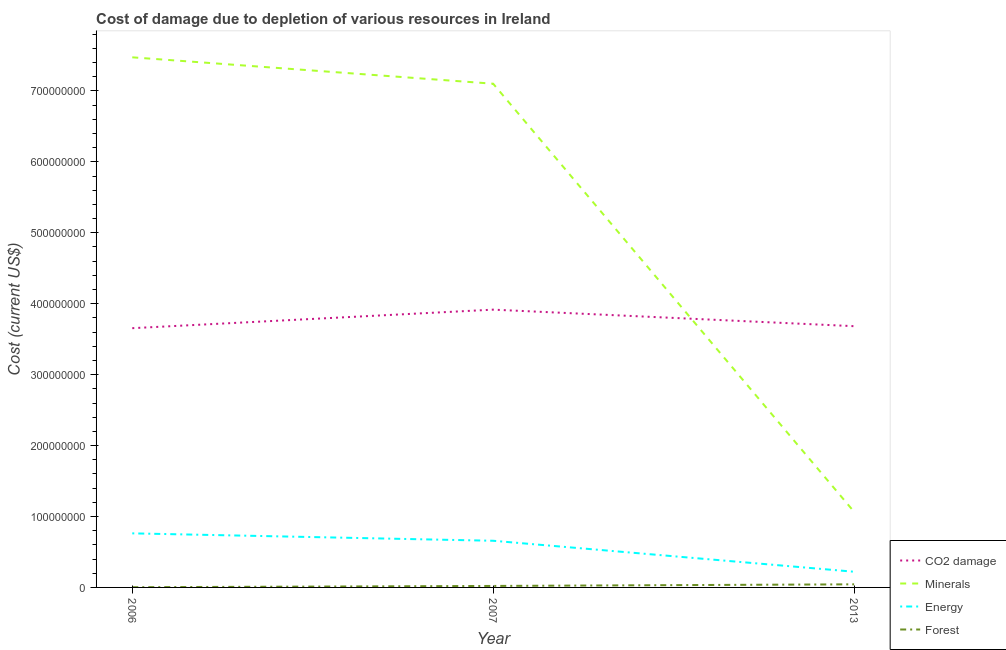Is the number of lines equal to the number of legend labels?
Give a very brief answer. Yes. What is the cost of damage due to depletion of forests in 2007?
Keep it short and to the point. 2.10e+06. Across all years, what is the maximum cost of damage due to depletion of minerals?
Ensure brevity in your answer.  7.47e+08. Across all years, what is the minimum cost of damage due to depletion of coal?
Your answer should be very brief. 3.65e+08. In which year was the cost of damage due to depletion of coal maximum?
Ensure brevity in your answer.  2007. In which year was the cost of damage due to depletion of forests minimum?
Your answer should be compact. 2006. What is the total cost of damage due to depletion of coal in the graph?
Provide a short and direct response. 1.13e+09. What is the difference between the cost of damage due to depletion of energy in 2006 and that in 2007?
Offer a very short reply. 1.05e+07. What is the difference between the cost of damage due to depletion of energy in 2007 and the cost of damage due to depletion of coal in 2013?
Provide a succinct answer. -3.03e+08. What is the average cost of damage due to depletion of energy per year?
Provide a succinct answer. 5.47e+07. In the year 2013, what is the difference between the cost of damage due to depletion of energy and cost of damage due to depletion of minerals?
Make the answer very short. -8.45e+07. What is the ratio of the cost of damage due to depletion of minerals in 2006 to that in 2007?
Your answer should be compact. 1.05. Is the cost of damage due to depletion of coal in 2006 less than that in 2007?
Your response must be concise. Yes. What is the difference between the highest and the second highest cost of damage due to depletion of minerals?
Offer a terse response. 3.72e+07. What is the difference between the highest and the lowest cost of damage due to depletion of forests?
Your answer should be compact. 4.07e+06. Is the sum of the cost of damage due to depletion of coal in 2007 and 2013 greater than the maximum cost of damage due to depletion of energy across all years?
Offer a very short reply. Yes. Is it the case that in every year, the sum of the cost of damage due to depletion of minerals and cost of damage due to depletion of forests is greater than the sum of cost of damage due to depletion of energy and cost of damage due to depletion of coal?
Keep it short and to the point. No. Is it the case that in every year, the sum of the cost of damage due to depletion of coal and cost of damage due to depletion of minerals is greater than the cost of damage due to depletion of energy?
Your answer should be very brief. Yes. Does the cost of damage due to depletion of coal monotonically increase over the years?
Provide a succinct answer. No. Is the cost of damage due to depletion of energy strictly greater than the cost of damage due to depletion of minerals over the years?
Your response must be concise. No. Where does the legend appear in the graph?
Offer a very short reply. Bottom right. What is the title of the graph?
Offer a very short reply. Cost of damage due to depletion of various resources in Ireland . Does "UNAIDS" appear as one of the legend labels in the graph?
Your response must be concise. No. What is the label or title of the Y-axis?
Keep it short and to the point. Cost (current US$). What is the Cost (current US$) of CO2 damage in 2006?
Give a very brief answer. 3.65e+08. What is the Cost (current US$) of Minerals in 2006?
Offer a very short reply. 7.47e+08. What is the Cost (current US$) in Energy in 2006?
Provide a short and direct response. 7.62e+07. What is the Cost (current US$) of Forest in 2006?
Your response must be concise. 2.94e+05. What is the Cost (current US$) in CO2 damage in 2007?
Provide a succinct answer. 3.92e+08. What is the Cost (current US$) in Minerals in 2007?
Your response must be concise. 7.10e+08. What is the Cost (current US$) of Energy in 2007?
Your response must be concise. 6.58e+07. What is the Cost (current US$) of Forest in 2007?
Give a very brief answer. 2.10e+06. What is the Cost (current US$) of CO2 damage in 2013?
Your answer should be very brief. 3.68e+08. What is the Cost (current US$) in Minerals in 2013?
Provide a short and direct response. 1.07e+08. What is the Cost (current US$) of Energy in 2013?
Keep it short and to the point. 2.21e+07. What is the Cost (current US$) in Forest in 2013?
Your answer should be compact. 4.37e+06. Across all years, what is the maximum Cost (current US$) of CO2 damage?
Your answer should be very brief. 3.92e+08. Across all years, what is the maximum Cost (current US$) of Minerals?
Your answer should be very brief. 7.47e+08. Across all years, what is the maximum Cost (current US$) of Energy?
Offer a very short reply. 7.62e+07. Across all years, what is the maximum Cost (current US$) of Forest?
Your answer should be compact. 4.37e+06. Across all years, what is the minimum Cost (current US$) of CO2 damage?
Your response must be concise. 3.65e+08. Across all years, what is the minimum Cost (current US$) in Minerals?
Ensure brevity in your answer.  1.07e+08. Across all years, what is the minimum Cost (current US$) of Energy?
Your response must be concise. 2.21e+07. Across all years, what is the minimum Cost (current US$) in Forest?
Keep it short and to the point. 2.94e+05. What is the total Cost (current US$) in CO2 damage in the graph?
Provide a succinct answer. 1.13e+09. What is the total Cost (current US$) of Minerals in the graph?
Provide a succinct answer. 1.56e+09. What is the total Cost (current US$) in Energy in the graph?
Provide a short and direct response. 1.64e+08. What is the total Cost (current US$) in Forest in the graph?
Your answer should be very brief. 6.76e+06. What is the difference between the Cost (current US$) in CO2 damage in 2006 and that in 2007?
Provide a succinct answer. -2.61e+07. What is the difference between the Cost (current US$) of Minerals in 2006 and that in 2007?
Offer a terse response. 3.72e+07. What is the difference between the Cost (current US$) of Energy in 2006 and that in 2007?
Give a very brief answer. 1.05e+07. What is the difference between the Cost (current US$) of Forest in 2006 and that in 2007?
Give a very brief answer. -1.81e+06. What is the difference between the Cost (current US$) in CO2 damage in 2006 and that in 2013?
Ensure brevity in your answer.  -2.81e+06. What is the difference between the Cost (current US$) in Minerals in 2006 and that in 2013?
Your answer should be compact. 6.41e+08. What is the difference between the Cost (current US$) of Energy in 2006 and that in 2013?
Ensure brevity in your answer.  5.41e+07. What is the difference between the Cost (current US$) of Forest in 2006 and that in 2013?
Give a very brief answer. -4.07e+06. What is the difference between the Cost (current US$) in CO2 damage in 2007 and that in 2013?
Your response must be concise. 2.33e+07. What is the difference between the Cost (current US$) in Minerals in 2007 and that in 2013?
Provide a short and direct response. 6.04e+08. What is the difference between the Cost (current US$) in Energy in 2007 and that in 2013?
Your answer should be very brief. 4.37e+07. What is the difference between the Cost (current US$) in Forest in 2007 and that in 2013?
Provide a short and direct response. -2.27e+06. What is the difference between the Cost (current US$) of CO2 damage in 2006 and the Cost (current US$) of Minerals in 2007?
Your answer should be compact. -3.45e+08. What is the difference between the Cost (current US$) in CO2 damage in 2006 and the Cost (current US$) in Energy in 2007?
Your response must be concise. 3.00e+08. What is the difference between the Cost (current US$) of CO2 damage in 2006 and the Cost (current US$) of Forest in 2007?
Your response must be concise. 3.63e+08. What is the difference between the Cost (current US$) in Minerals in 2006 and the Cost (current US$) in Energy in 2007?
Provide a short and direct response. 6.82e+08. What is the difference between the Cost (current US$) in Minerals in 2006 and the Cost (current US$) in Forest in 2007?
Your answer should be compact. 7.45e+08. What is the difference between the Cost (current US$) of Energy in 2006 and the Cost (current US$) of Forest in 2007?
Your answer should be very brief. 7.41e+07. What is the difference between the Cost (current US$) in CO2 damage in 2006 and the Cost (current US$) in Minerals in 2013?
Make the answer very short. 2.59e+08. What is the difference between the Cost (current US$) in CO2 damage in 2006 and the Cost (current US$) in Energy in 2013?
Provide a short and direct response. 3.43e+08. What is the difference between the Cost (current US$) in CO2 damage in 2006 and the Cost (current US$) in Forest in 2013?
Give a very brief answer. 3.61e+08. What is the difference between the Cost (current US$) of Minerals in 2006 and the Cost (current US$) of Energy in 2013?
Your response must be concise. 7.25e+08. What is the difference between the Cost (current US$) in Minerals in 2006 and the Cost (current US$) in Forest in 2013?
Your answer should be compact. 7.43e+08. What is the difference between the Cost (current US$) of Energy in 2006 and the Cost (current US$) of Forest in 2013?
Keep it short and to the point. 7.19e+07. What is the difference between the Cost (current US$) in CO2 damage in 2007 and the Cost (current US$) in Minerals in 2013?
Keep it short and to the point. 2.85e+08. What is the difference between the Cost (current US$) in CO2 damage in 2007 and the Cost (current US$) in Energy in 2013?
Offer a terse response. 3.70e+08. What is the difference between the Cost (current US$) of CO2 damage in 2007 and the Cost (current US$) of Forest in 2013?
Offer a terse response. 3.87e+08. What is the difference between the Cost (current US$) of Minerals in 2007 and the Cost (current US$) of Energy in 2013?
Offer a terse response. 6.88e+08. What is the difference between the Cost (current US$) in Minerals in 2007 and the Cost (current US$) in Forest in 2013?
Offer a very short reply. 7.06e+08. What is the difference between the Cost (current US$) of Energy in 2007 and the Cost (current US$) of Forest in 2013?
Keep it short and to the point. 6.14e+07. What is the average Cost (current US$) in CO2 damage per year?
Ensure brevity in your answer.  3.75e+08. What is the average Cost (current US$) in Minerals per year?
Keep it short and to the point. 5.21e+08. What is the average Cost (current US$) in Energy per year?
Make the answer very short. 5.47e+07. What is the average Cost (current US$) in Forest per year?
Give a very brief answer. 2.25e+06. In the year 2006, what is the difference between the Cost (current US$) of CO2 damage and Cost (current US$) of Minerals?
Provide a succinct answer. -3.82e+08. In the year 2006, what is the difference between the Cost (current US$) in CO2 damage and Cost (current US$) in Energy?
Your response must be concise. 2.89e+08. In the year 2006, what is the difference between the Cost (current US$) in CO2 damage and Cost (current US$) in Forest?
Your answer should be compact. 3.65e+08. In the year 2006, what is the difference between the Cost (current US$) in Minerals and Cost (current US$) in Energy?
Your answer should be compact. 6.71e+08. In the year 2006, what is the difference between the Cost (current US$) of Minerals and Cost (current US$) of Forest?
Give a very brief answer. 7.47e+08. In the year 2006, what is the difference between the Cost (current US$) in Energy and Cost (current US$) in Forest?
Provide a succinct answer. 7.59e+07. In the year 2007, what is the difference between the Cost (current US$) in CO2 damage and Cost (current US$) in Minerals?
Offer a terse response. -3.19e+08. In the year 2007, what is the difference between the Cost (current US$) in CO2 damage and Cost (current US$) in Energy?
Keep it short and to the point. 3.26e+08. In the year 2007, what is the difference between the Cost (current US$) in CO2 damage and Cost (current US$) in Forest?
Your answer should be very brief. 3.90e+08. In the year 2007, what is the difference between the Cost (current US$) in Minerals and Cost (current US$) in Energy?
Your response must be concise. 6.44e+08. In the year 2007, what is the difference between the Cost (current US$) of Minerals and Cost (current US$) of Forest?
Provide a succinct answer. 7.08e+08. In the year 2007, what is the difference between the Cost (current US$) of Energy and Cost (current US$) of Forest?
Provide a short and direct response. 6.37e+07. In the year 2013, what is the difference between the Cost (current US$) of CO2 damage and Cost (current US$) of Minerals?
Your answer should be compact. 2.62e+08. In the year 2013, what is the difference between the Cost (current US$) of CO2 damage and Cost (current US$) of Energy?
Make the answer very short. 3.46e+08. In the year 2013, what is the difference between the Cost (current US$) in CO2 damage and Cost (current US$) in Forest?
Give a very brief answer. 3.64e+08. In the year 2013, what is the difference between the Cost (current US$) in Minerals and Cost (current US$) in Energy?
Give a very brief answer. 8.45e+07. In the year 2013, what is the difference between the Cost (current US$) in Minerals and Cost (current US$) in Forest?
Your answer should be compact. 1.02e+08. In the year 2013, what is the difference between the Cost (current US$) of Energy and Cost (current US$) of Forest?
Give a very brief answer. 1.77e+07. What is the ratio of the Cost (current US$) of CO2 damage in 2006 to that in 2007?
Give a very brief answer. 0.93. What is the ratio of the Cost (current US$) of Minerals in 2006 to that in 2007?
Your answer should be very brief. 1.05. What is the ratio of the Cost (current US$) in Energy in 2006 to that in 2007?
Offer a terse response. 1.16. What is the ratio of the Cost (current US$) of Forest in 2006 to that in 2007?
Your answer should be very brief. 0.14. What is the ratio of the Cost (current US$) of Minerals in 2006 to that in 2013?
Give a very brief answer. 7.01. What is the ratio of the Cost (current US$) of Energy in 2006 to that in 2013?
Ensure brevity in your answer.  3.45. What is the ratio of the Cost (current US$) of Forest in 2006 to that in 2013?
Offer a terse response. 0.07. What is the ratio of the Cost (current US$) in CO2 damage in 2007 to that in 2013?
Provide a succinct answer. 1.06. What is the ratio of the Cost (current US$) in Minerals in 2007 to that in 2013?
Make the answer very short. 6.66. What is the ratio of the Cost (current US$) of Energy in 2007 to that in 2013?
Keep it short and to the point. 2.97. What is the ratio of the Cost (current US$) in Forest in 2007 to that in 2013?
Offer a terse response. 0.48. What is the difference between the highest and the second highest Cost (current US$) of CO2 damage?
Make the answer very short. 2.33e+07. What is the difference between the highest and the second highest Cost (current US$) in Minerals?
Your answer should be very brief. 3.72e+07. What is the difference between the highest and the second highest Cost (current US$) of Energy?
Ensure brevity in your answer.  1.05e+07. What is the difference between the highest and the second highest Cost (current US$) of Forest?
Keep it short and to the point. 2.27e+06. What is the difference between the highest and the lowest Cost (current US$) in CO2 damage?
Give a very brief answer. 2.61e+07. What is the difference between the highest and the lowest Cost (current US$) of Minerals?
Your answer should be very brief. 6.41e+08. What is the difference between the highest and the lowest Cost (current US$) of Energy?
Offer a very short reply. 5.41e+07. What is the difference between the highest and the lowest Cost (current US$) of Forest?
Ensure brevity in your answer.  4.07e+06. 